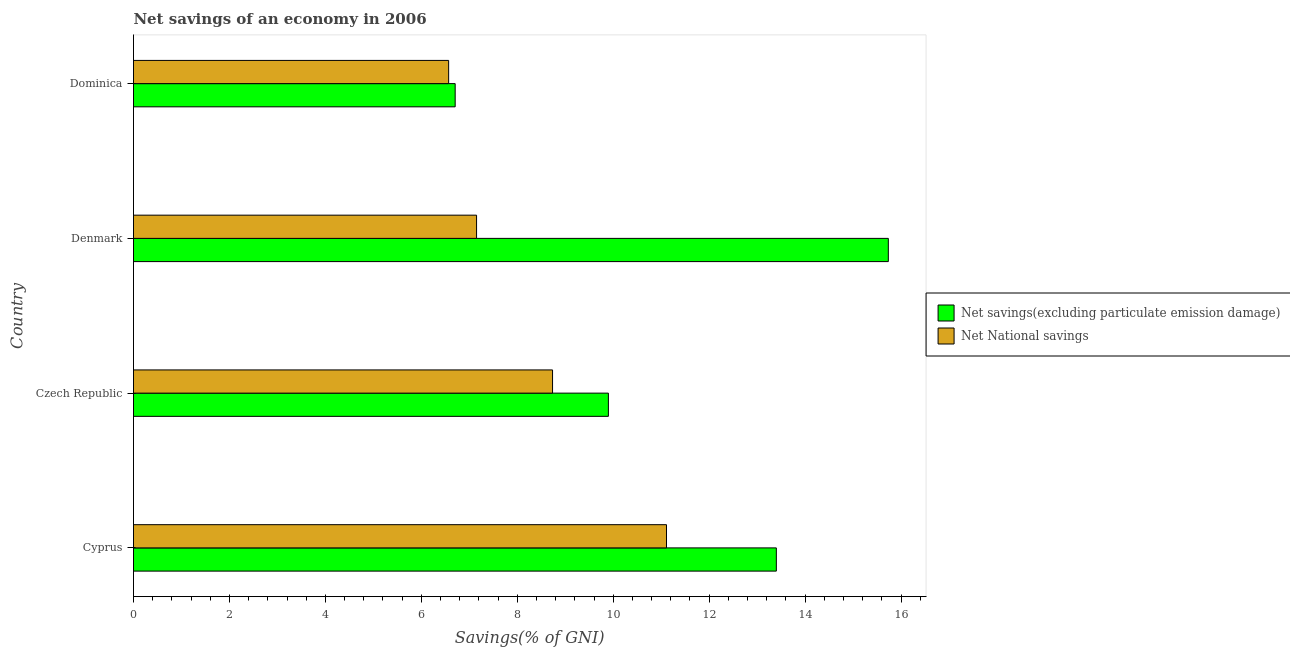How many different coloured bars are there?
Make the answer very short. 2. How many groups of bars are there?
Your response must be concise. 4. Are the number of bars per tick equal to the number of legend labels?
Give a very brief answer. Yes. How many bars are there on the 3rd tick from the bottom?
Give a very brief answer. 2. What is the label of the 1st group of bars from the top?
Ensure brevity in your answer.  Dominica. What is the net national savings in Dominica?
Offer a very short reply. 6.57. Across all countries, what is the maximum net savings(excluding particulate emission damage)?
Keep it short and to the point. 15.74. Across all countries, what is the minimum net national savings?
Keep it short and to the point. 6.57. In which country was the net national savings maximum?
Provide a succinct answer. Cyprus. In which country was the net national savings minimum?
Ensure brevity in your answer.  Dominica. What is the total net savings(excluding particulate emission damage) in the graph?
Offer a terse response. 45.74. What is the difference between the net national savings in Cyprus and that in Czech Republic?
Provide a short and direct response. 2.38. What is the difference between the net national savings in Cyprus and the net savings(excluding particulate emission damage) in Dominica?
Ensure brevity in your answer.  4.41. What is the average net national savings per country?
Your answer should be very brief. 8.39. What is the difference between the net savings(excluding particulate emission damage) and net national savings in Cyprus?
Provide a succinct answer. 2.29. In how many countries, is the net national savings greater than 10.4 %?
Give a very brief answer. 1. What is the ratio of the net savings(excluding particulate emission damage) in Cyprus to that in Czech Republic?
Your answer should be compact. 1.35. What is the difference between the highest and the second highest net national savings?
Give a very brief answer. 2.38. What is the difference between the highest and the lowest net national savings?
Offer a terse response. 4.54. In how many countries, is the net savings(excluding particulate emission damage) greater than the average net savings(excluding particulate emission damage) taken over all countries?
Keep it short and to the point. 2. What does the 1st bar from the top in Cyprus represents?
Give a very brief answer. Net National savings. What does the 1st bar from the bottom in Dominica represents?
Make the answer very short. Net savings(excluding particulate emission damage). How many bars are there?
Offer a very short reply. 8. Are all the bars in the graph horizontal?
Your response must be concise. Yes. What is the difference between two consecutive major ticks on the X-axis?
Your response must be concise. 2. Are the values on the major ticks of X-axis written in scientific E-notation?
Keep it short and to the point. No. Does the graph contain any zero values?
Provide a short and direct response. No. How are the legend labels stacked?
Your response must be concise. Vertical. What is the title of the graph?
Provide a short and direct response. Net savings of an economy in 2006. What is the label or title of the X-axis?
Provide a short and direct response. Savings(% of GNI). What is the label or title of the Y-axis?
Ensure brevity in your answer.  Country. What is the Savings(% of GNI) in Net savings(excluding particulate emission damage) in Cyprus?
Your response must be concise. 13.4. What is the Savings(% of GNI) in Net National savings in Cyprus?
Give a very brief answer. 11.11. What is the Savings(% of GNI) of Net savings(excluding particulate emission damage) in Czech Republic?
Your answer should be very brief. 9.9. What is the Savings(% of GNI) in Net National savings in Czech Republic?
Ensure brevity in your answer.  8.74. What is the Savings(% of GNI) in Net savings(excluding particulate emission damage) in Denmark?
Ensure brevity in your answer.  15.74. What is the Savings(% of GNI) in Net National savings in Denmark?
Offer a very short reply. 7.15. What is the Savings(% of GNI) of Net savings(excluding particulate emission damage) in Dominica?
Offer a terse response. 6.71. What is the Savings(% of GNI) in Net National savings in Dominica?
Your response must be concise. 6.57. Across all countries, what is the maximum Savings(% of GNI) in Net savings(excluding particulate emission damage)?
Provide a short and direct response. 15.74. Across all countries, what is the maximum Savings(% of GNI) of Net National savings?
Your answer should be compact. 11.11. Across all countries, what is the minimum Savings(% of GNI) of Net savings(excluding particulate emission damage)?
Offer a terse response. 6.71. Across all countries, what is the minimum Savings(% of GNI) in Net National savings?
Offer a terse response. 6.57. What is the total Savings(% of GNI) in Net savings(excluding particulate emission damage) in the graph?
Keep it short and to the point. 45.74. What is the total Savings(% of GNI) of Net National savings in the graph?
Give a very brief answer. 33.57. What is the difference between the Savings(% of GNI) in Net savings(excluding particulate emission damage) in Cyprus and that in Czech Republic?
Your response must be concise. 3.5. What is the difference between the Savings(% of GNI) in Net National savings in Cyprus and that in Czech Republic?
Your answer should be very brief. 2.38. What is the difference between the Savings(% of GNI) of Net savings(excluding particulate emission damage) in Cyprus and that in Denmark?
Your answer should be very brief. -2.33. What is the difference between the Savings(% of GNI) of Net National savings in Cyprus and that in Denmark?
Your response must be concise. 3.96. What is the difference between the Savings(% of GNI) in Net savings(excluding particulate emission damage) in Cyprus and that in Dominica?
Keep it short and to the point. 6.7. What is the difference between the Savings(% of GNI) in Net National savings in Cyprus and that in Dominica?
Provide a short and direct response. 4.54. What is the difference between the Savings(% of GNI) of Net savings(excluding particulate emission damage) in Czech Republic and that in Denmark?
Make the answer very short. -5.84. What is the difference between the Savings(% of GNI) of Net National savings in Czech Republic and that in Denmark?
Your answer should be very brief. 1.58. What is the difference between the Savings(% of GNI) of Net savings(excluding particulate emission damage) in Czech Republic and that in Dominica?
Your answer should be compact. 3.19. What is the difference between the Savings(% of GNI) of Net National savings in Czech Republic and that in Dominica?
Make the answer very short. 2.17. What is the difference between the Savings(% of GNI) in Net savings(excluding particulate emission damage) in Denmark and that in Dominica?
Make the answer very short. 9.03. What is the difference between the Savings(% of GNI) of Net National savings in Denmark and that in Dominica?
Ensure brevity in your answer.  0.58. What is the difference between the Savings(% of GNI) of Net savings(excluding particulate emission damage) in Cyprus and the Savings(% of GNI) of Net National savings in Czech Republic?
Offer a terse response. 4.67. What is the difference between the Savings(% of GNI) of Net savings(excluding particulate emission damage) in Cyprus and the Savings(% of GNI) of Net National savings in Denmark?
Your answer should be very brief. 6.25. What is the difference between the Savings(% of GNI) in Net savings(excluding particulate emission damage) in Cyprus and the Savings(% of GNI) in Net National savings in Dominica?
Make the answer very short. 6.83. What is the difference between the Savings(% of GNI) of Net savings(excluding particulate emission damage) in Czech Republic and the Savings(% of GNI) of Net National savings in Denmark?
Give a very brief answer. 2.75. What is the difference between the Savings(% of GNI) in Net savings(excluding particulate emission damage) in Czech Republic and the Savings(% of GNI) in Net National savings in Dominica?
Offer a very short reply. 3.33. What is the difference between the Savings(% of GNI) of Net savings(excluding particulate emission damage) in Denmark and the Savings(% of GNI) of Net National savings in Dominica?
Provide a succinct answer. 9.17. What is the average Savings(% of GNI) of Net savings(excluding particulate emission damage) per country?
Ensure brevity in your answer.  11.44. What is the average Savings(% of GNI) in Net National savings per country?
Offer a terse response. 8.39. What is the difference between the Savings(% of GNI) in Net savings(excluding particulate emission damage) and Savings(% of GNI) in Net National savings in Cyprus?
Ensure brevity in your answer.  2.29. What is the difference between the Savings(% of GNI) of Net savings(excluding particulate emission damage) and Savings(% of GNI) of Net National savings in Czech Republic?
Give a very brief answer. 1.16. What is the difference between the Savings(% of GNI) in Net savings(excluding particulate emission damage) and Savings(% of GNI) in Net National savings in Denmark?
Offer a terse response. 8.58. What is the difference between the Savings(% of GNI) of Net savings(excluding particulate emission damage) and Savings(% of GNI) of Net National savings in Dominica?
Your answer should be very brief. 0.14. What is the ratio of the Savings(% of GNI) in Net savings(excluding particulate emission damage) in Cyprus to that in Czech Republic?
Provide a short and direct response. 1.35. What is the ratio of the Savings(% of GNI) of Net National savings in Cyprus to that in Czech Republic?
Offer a very short reply. 1.27. What is the ratio of the Savings(% of GNI) in Net savings(excluding particulate emission damage) in Cyprus to that in Denmark?
Your answer should be compact. 0.85. What is the ratio of the Savings(% of GNI) in Net National savings in Cyprus to that in Denmark?
Give a very brief answer. 1.55. What is the ratio of the Savings(% of GNI) in Net savings(excluding particulate emission damage) in Cyprus to that in Dominica?
Offer a terse response. 2. What is the ratio of the Savings(% of GNI) in Net National savings in Cyprus to that in Dominica?
Provide a short and direct response. 1.69. What is the ratio of the Savings(% of GNI) of Net savings(excluding particulate emission damage) in Czech Republic to that in Denmark?
Your response must be concise. 0.63. What is the ratio of the Savings(% of GNI) of Net National savings in Czech Republic to that in Denmark?
Your response must be concise. 1.22. What is the ratio of the Savings(% of GNI) of Net savings(excluding particulate emission damage) in Czech Republic to that in Dominica?
Give a very brief answer. 1.48. What is the ratio of the Savings(% of GNI) of Net National savings in Czech Republic to that in Dominica?
Offer a very short reply. 1.33. What is the ratio of the Savings(% of GNI) of Net savings(excluding particulate emission damage) in Denmark to that in Dominica?
Ensure brevity in your answer.  2.35. What is the ratio of the Savings(% of GNI) in Net National savings in Denmark to that in Dominica?
Make the answer very short. 1.09. What is the difference between the highest and the second highest Savings(% of GNI) in Net savings(excluding particulate emission damage)?
Keep it short and to the point. 2.33. What is the difference between the highest and the second highest Savings(% of GNI) in Net National savings?
Give a very brief answer. 2.38. What is the difference between the highest and the lowest Savings(% of GNI) of Net savings(excluding particulate emission damage)?
Your answer should be compact. 9.03. What is the difference between the highest and the lowest Savings(% of GNI) of Net National savings?
Offer a very short reply. 4.54. 